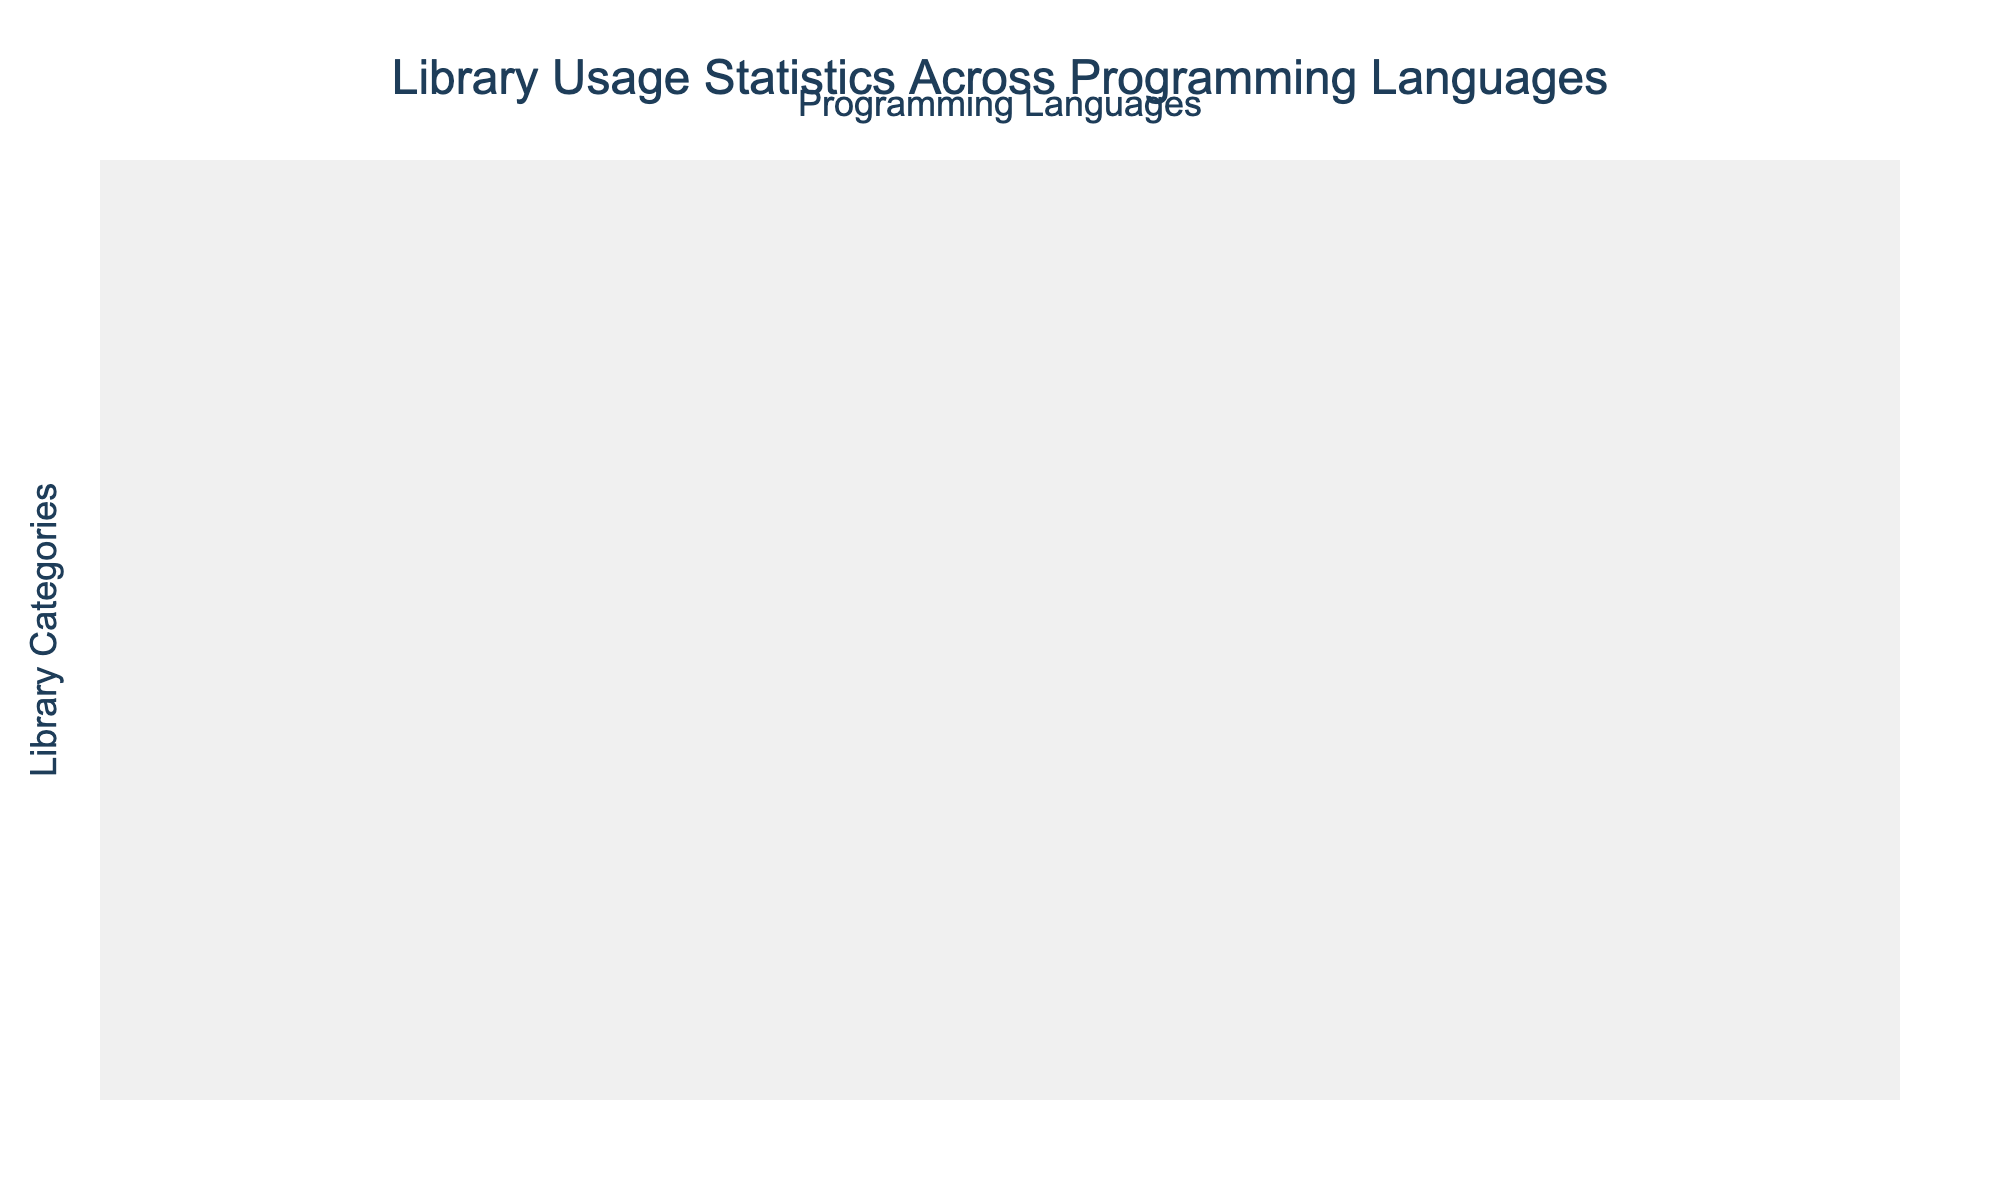What is the highest percentage for Package Management in any programming language? The highest value in the Package Management category is 95%, which belongs to JavaScript.
Answer: 95% Which programming language has the lowest percentage for ORM/Database Access? The percentages for ORM/Database Access are Java 86%, Go 75%, C++ 70%, Python 89%, Ruby 80%, JavaScript 82%, Rust 72%, and TypeScript 84%. The lowest percentage is 70% from C++.
Answer: C++ What is the average percentage for Unit Testing across all programming languages? The percentages for Unit Testing are 90%, 94%, 92%, 85%, 88%, 91%, 93%, 92%. The sum is 90 + 94 + 92 + 85 + 88 + 91 + 93 + 92 = 725. There are 8 languages, so the average is 725 / 8 = 90.625%.
Answer: 90.625% Is the percentage for Logging in Ruby higher than that in Go? Logging in Ruby is 84% and in Go it is 87%. Therefore, Ruby's percentage is lower than Go's.
Answer: No What is the difference in percentage for JSON Parsing between JavaScript and C++? The percentage for JSON Parsing in JavaScript is 96%, and for C++, it is 82%. The difference is 96% - 82% = 14%.
Answer: 14% How many library categories have a percentage above 90% for Python? The percentages for Python across the categories are: Package Management 92%, Documentation Generation 88%, Unit Testing 94%, Dependency Injection 82%, Logging 90%, ORM/Database Access 89%, HTTP Client 91%, JSON Parsing 93%, Date/Time Handling 92%, and Cryptography 83%. Counting the values above 90%, we find the categories are: Package Management, Unit Testing, Logging, HTTP Client, JSON Parsing, and Date/Time Handling, totaling 6 categories.
Answer: 6 Which programming language has the highest percentage for Dependency Injection? Evaluating the Dependency Injection percentages: Java 90%, JavaScript 78%, Python 82%, C++ 72%, Ruby 76%, Go 80%, Rust 70%, TypeScript 85%. The highest percentage is 90% from Java.
Answer: Java What are the two programming languages that have the closest percentages for Date/Time Handling? The percentages for Date/Time Handling are 85%, 92%, 89%, 80%, 87%, 86%, 84%, and 91% for the languages respectively. The closest values are 89% (Java) and 87% (Ruby), which differ by 2%.
Answer: Java and Ruby Does any programming language have a percentage of 100% for any library category? Looking at all percentages, none reach 100%. The highest values are below that, indicating no language has a perfect score in any category.
Answer: No Compare the percentage of Dependency Injection in TypeScript and C++. Which one is higher and by how much? The percentage for Dependency Injection in TypeScript is 85%, and in C++, it is 72%. The difference is 85% - 72% = 13%.
Answer: TypeScript is higher by 13% 